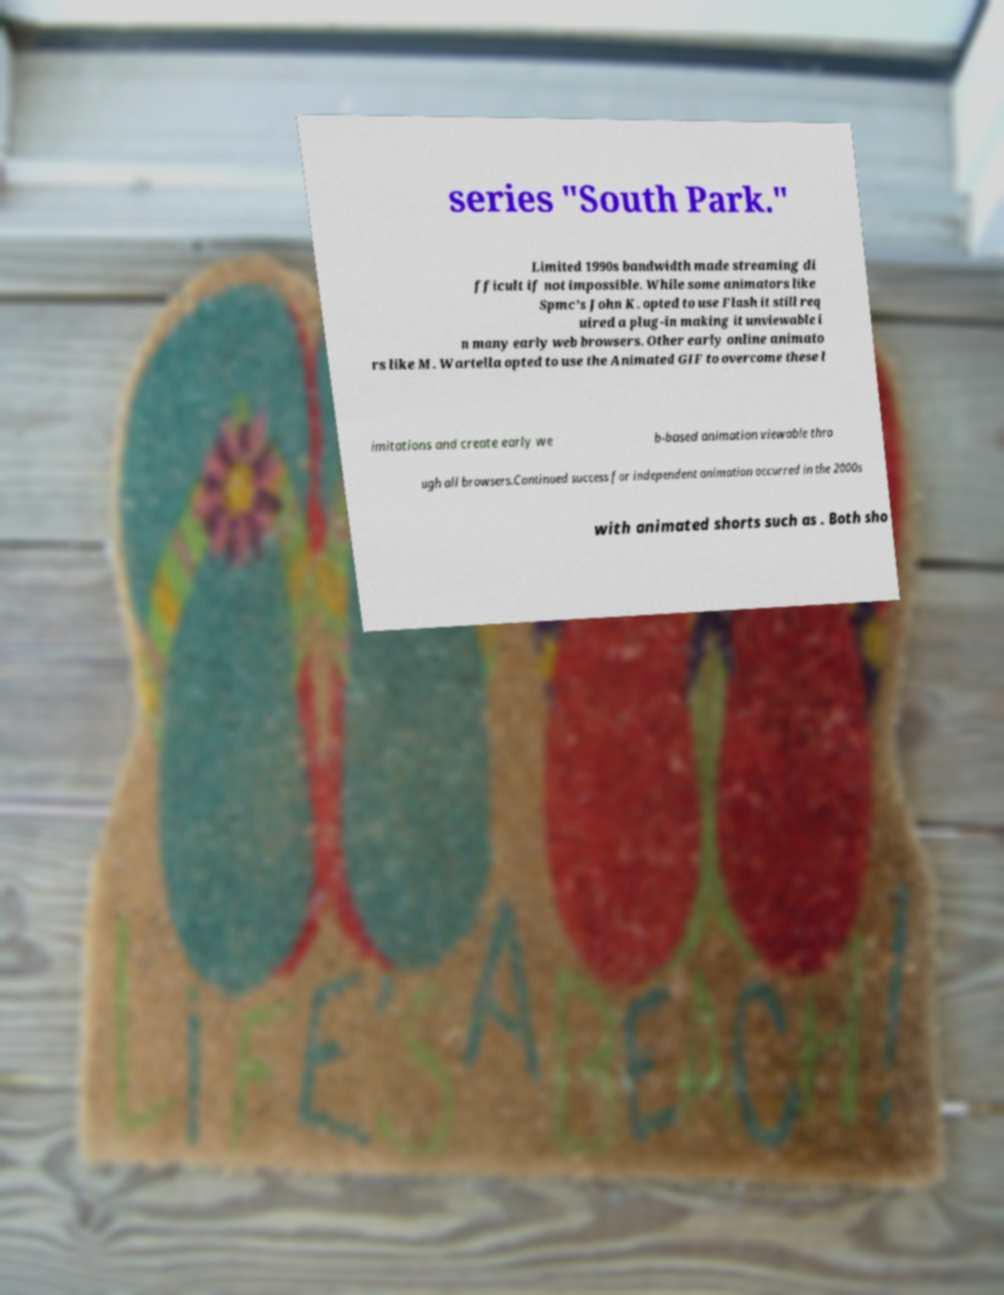Please read and relay the text visible in this image. What does it say? series "South Park." Limited 1990s bandwidth made streaming di fficult if not impossible. While some animators like Spmc's John K. opted to use Flash it still req uired a plug-in making it unviewable i n many early web browsers. Other early online animato rs like M. Wartella opted to use the Animated GIF to overcome these l imitations and create early we b-based animation viewable thro ugh all browsers.Continued success for independent animation occurred in the 2000s with animated shorts such as . Both sho 